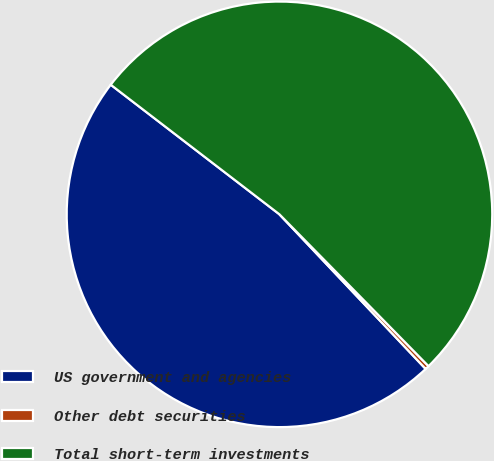Convert chart to OTSL. <chart><loc_0><loc_0><loc_500><loc_500><pie_chart><fcel>US government and agencies<fcel>Other debt securities<fcel>Total short-term investments<nl><fcel>47.48%<fcel>0.3%<fcel>52.22%<nl></chart> 